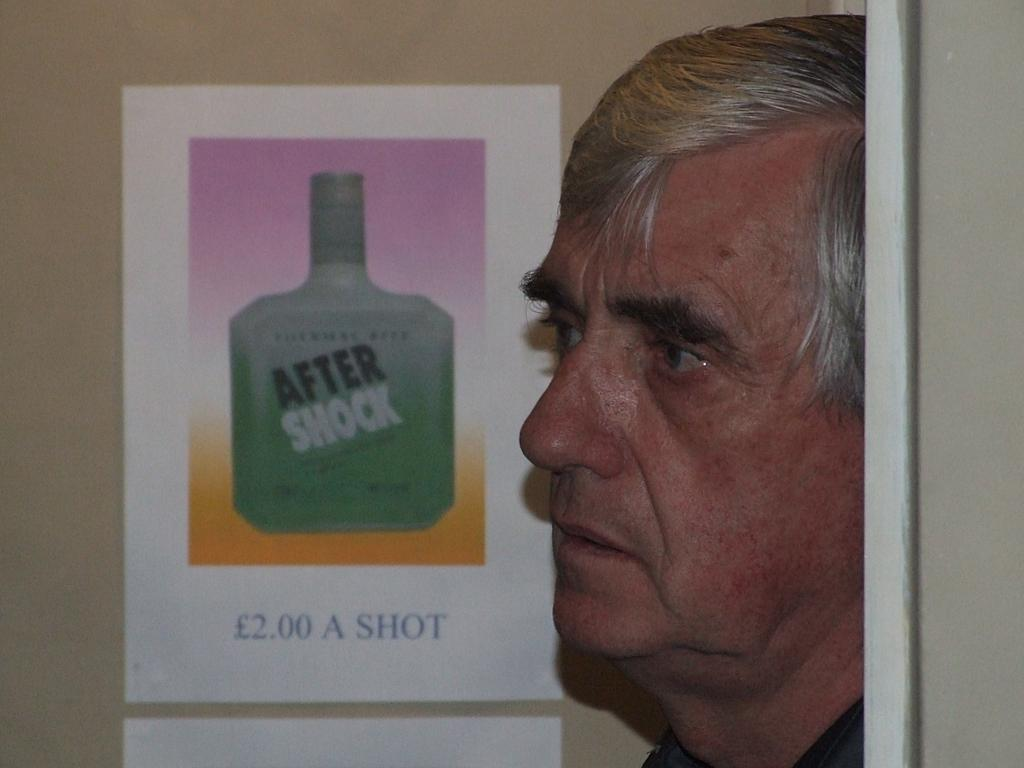What is the main subject of the image? There is a person's face in the image. What can be seen on the paper in the image? There is an aftershock bottle on a paper in the image. How is the paper with the aftershock bottle positioned in the image? The paper is attached to the wall. What type of cake is being served on the roof in the image? There is no cake or roof present in the image. What kind of system is responsible for the aftershock bottle's presence on the paper in the image? The image does not provide information about a system responsible for the aftershock bottle's presence on the paper. 